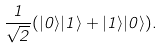Convert formula to latex. <formula><loc_0><loc_0><loc_500><loc_500>\frac { 1 } { \sqrt { 2 } } ( | 0 \rangle | 1 \rangle + | 1 \rangle | 0 \rangle ) .</formula> 